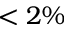Convert formula to latex. <formula><loc_0><loc_0><loc_500><loc_500>< 2 \%</formula> 